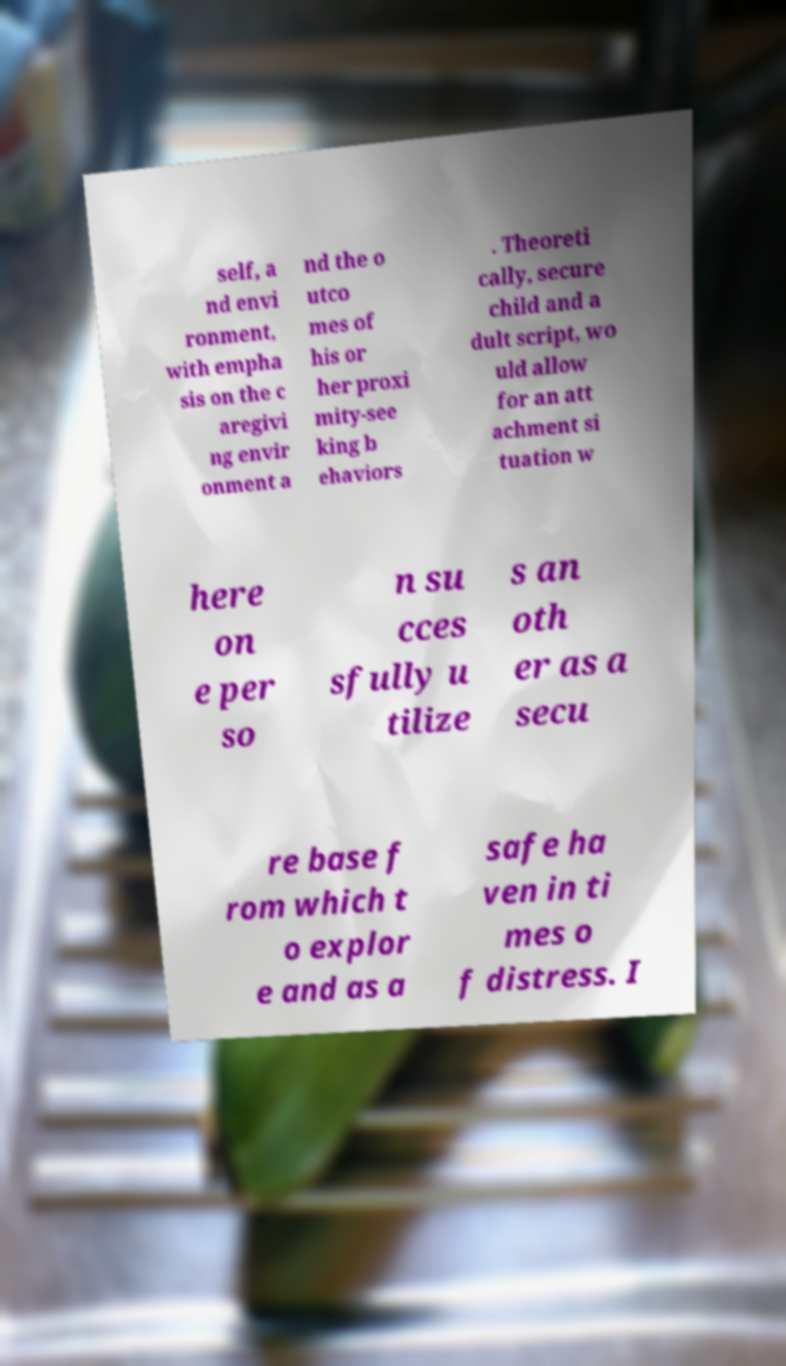Can you accurately transcribe the text from the provided image for me? self, a nd envi ronment, with empha sis on the c aregivi ng envir onment a nd the o utco mes of his or her proxi mity-see king b ehaviors . Theoreti cally, secure child and a dult script, wo uld allow for an att achment si tuation w here on e per so n su cces sfully u tilize s an oth er as a secu re base f rom which t o explor e and as a safe ha ven in ti mes o f distress. I 